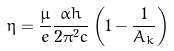Convert formula to latex. <formula><loc_0><loc_0><loc_500><loc_500>\eta = \frac { \mu } { e } \frac { \alpha h } { 2 \pi ^ { 2 } c } \left ( 1 - \frac { 1 } { A _ { k } } \right )</formula> 